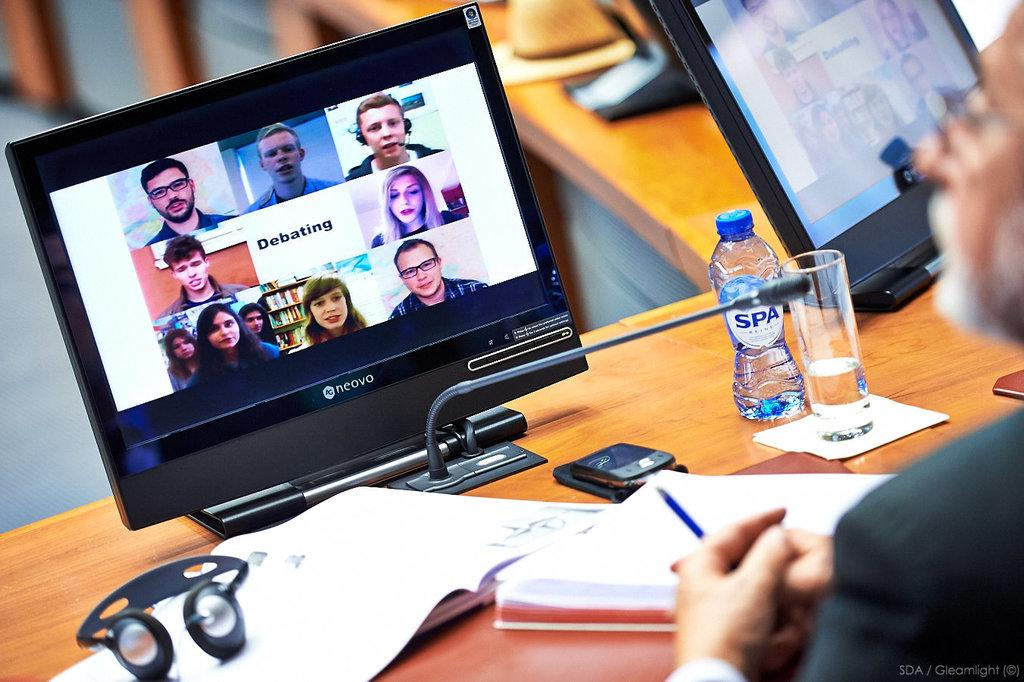<image>
Offer a succinct explanation of the picture presented. a man looking at a Neovo screen with lots of others on it 